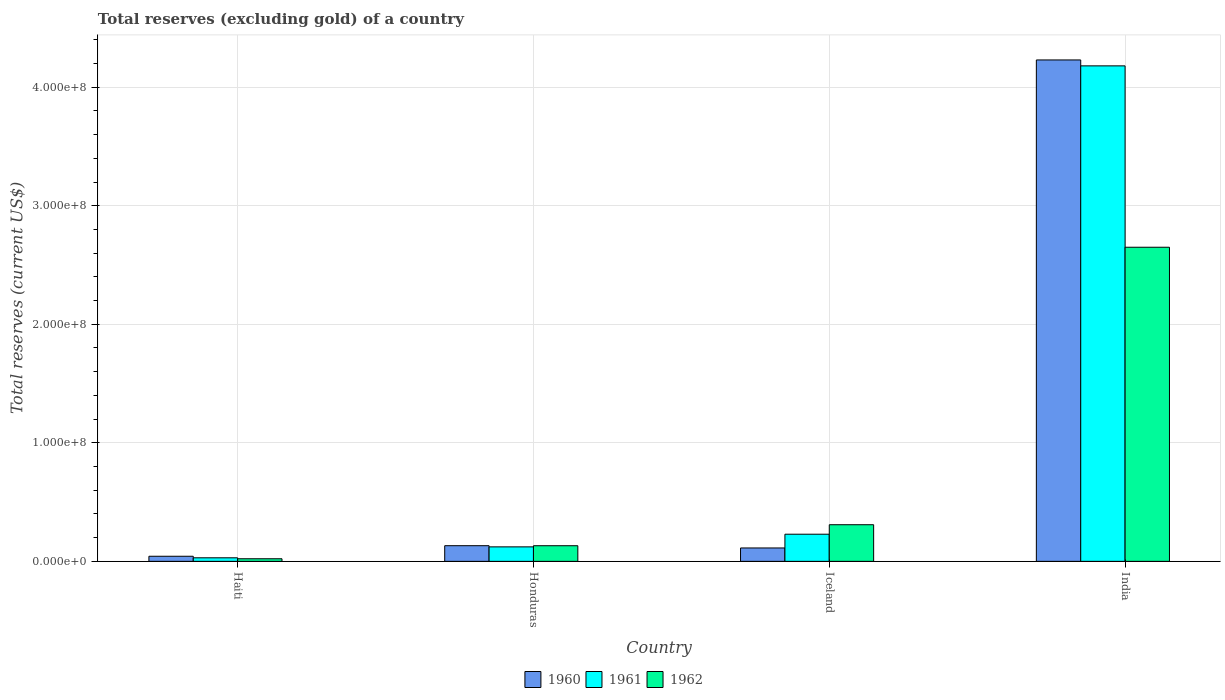How many different coloured bars are there?
Your answer should be compact. 3. Are the number of bars on each tick of the X-axis equal?
Keep it short and to the point. Yes. In how many cases, is the number of bars for a given country not equal to the number of legend labels?
Ensure brevity in your answer.  0. What is the total reserves (excluding gold) in 1962 in Honduras?
Keep it short and to the point. 1.32e+07. Across all countries, what is the maximum total reserves (excluding gold) in 1962?
Offer a very short reply. 2.65e+08. Across all countries, what is the minimum total reserves (excluding gold) in 1960?
Your response must be concise. 4.30e+06. In which country was the total reserves (excluding gold) in 1961 minimum?
Your response must be concise. Haiti. What is the total total reserves (excluding gold) in 1962 in the graph?
Ensure brevity in your answer.  3.11e+08. What is the difference between the total reserves (excluding gold) in 1961 in Honduras and that in India?
Your answer should be very brief. -4.06e+08. What is the difference between the total reserves (excluding gold) in 1960 in Iceland and the total reserves (excluding gold) in 1961 in Haiti?
Offer a terse response. 8.30e+06. What is the average total reserves (excluding gold) in 1961 per country?
Your response must be concise. 1.14e+08. What is the difference between the total reserves (excluding gold) of/in 1961 and total reserves (excluding gold) of/in 1960 in Iceland?
Your answer should be compact. 1.16e+07. In how many countries, is the total reserves (excluding gold) in 1961 greater than 20000000 US$?
Your answer should be very brief. 2. What is the ratio of the total reserves (excluding gold) in 1960 in Honduras to that in Iceland?
Your response must be concise. 1.17. Is the difference between the total reserves (excluding gold) in 1961 in Haiti and Iceland greater than the difference between the total reserves (excluding gold) in 1960 in Haiti and Iceland?
Your answer should be very brief. No. What is the difference between the highest and the second highest total reserves (excluding gold) in 1962?
Offer a terse response. 2.34e+08. What is the difference between the highest and the lowest total reserves (excluding gold) in 1960?
Offer a terse response. 4.19e+08. Is the sum of the total reserves (excluding gold) in 1962 in Honduras and Iceland greater than the maximum total reserves (excluding gold) in 1961 across all countries?
Offer a very short reply. No. How many bars are there?
Your answer should be very brief. 12. Are all the bars in the graph horizontal?
Your answer should be compact. No. How many countries are there in the graph?
Offer a very short reply. 4. What is the difference between two consecutive major ticks on the Y-axis?
Provide a succinct answer. 1.00e+08. Does the graph contain any zero values?
Keep it short and to the point. No. Does the graph contain grids?
Keep it short and to the point. Yes. Where does the legend appear in the graph?
Your answer should be compact. Bottom center. How many legend labels are there?
Provide a short and direct response. 3. What is the title of the graph?
Offer a terse response. Total reserves (excluding gold) of a country. What is the label or title of the Y-axis?
Your response must be concise. Total reserves (current US$). What is the Total reserves (current US$) in 1960 in Haiti?
Make the answer very short. 4.30e+06. What is the Total reserves (current US$) of 1962 in Haiti?
Give a very brief answer. 2.20e+06. What is the Total reserves (current US$) of 1960 in Honduras?
Give a very brief answer. 1.32e+07. What is the Total reserves (current US$) of 1961 in Honduras?
Make the answer very short. 1.22e+07. What is the Total reserves (current US$) of 1962 in Honduras?
Give a very brief answer. 1.32e+07. What is the Total reserves (current US$) in 1960 in Iceland?
Give a very brief answer. 1.13e+07. What is the Total reserves (current US$) of 1961 in Iceland?
Provide a succinct answer. 2.29e+07. What is the Total reserves (current US$) in 1962 in Iceland?
Offer a terse response. 3.09e+07. What is the Total reserves (current US$) of 1960 in India?
Keep it short and to the point. 4.23e+08. What is the Total reserves (current US$) in 1961 in India?
Provide a short and direct response. 4.18e+08. What is the Total reserves (current US$) of 1962 in India?
Make the answer very short. 2.65e+08. Across all countries, what is the maximum Total reserves (current US$) of 1960?
Make the answer very short. 4.23e+08. Across all countries, what is the maximum Total reserves (current US$) of 1961?
Offer a very short reply. 4.18e+08. Across all countries, what is the maximum Total reserves (current US$) of 1962?
Provide a succinct answer. 2.65e+08. Across all countries, what is the minimum Total reserves (current US$) of 1960?
Offer a terse response. 4.30e+06. Across all countries, what is the minimum Total reserves (current US$) of 1961?
Make the answer very short. 3.00e+06. Across all countries, what is the minimum Total reserves (current US$) of 1962?
Give a very brief answer. 2.20e+06. What is the total Total reserves (current US$) of 1960 in the graph?
Ensure brevity in your answer.  4.52e+08. What is the total Total reserves (current US$) of 1961 in the graph?
Provide a short and direct response. 4.56e+08. What is the total Total reserves (current US$) in 1962 in the graph?
Your answer should be very brief. 3.11e+08. What is the difference between the Total reserves (current US$) in 1960 in Haiti and that in Honduras?
Your response must be concise. -8.91e+06. What is the difference between the Total reserves (current US$) in 1961 in Haiti and that in Honduras?
Keep it short and to the point. -9.22e+06. What is the difference between the Total reserves (current US$) of 1962 in Haiti and that in Honduras?
Provide a short and direct response. -1.10e+07. What is the difference between the Total reserves (current US$) of 1960 in Haiti and that in Iceland?
Provide a short and direct response. -7.00e+06. What is the difference between the Total reserves (current US$) in 1961 in Haiti and that in Iceland?
Provide a short and direct response. -1.99e+07. What is the difference between the Total reserves (current US$) of 1962 in Haiti and that in Iceland?
Give a very brief answer. -2.87e+07. What is the difference between the Total reserves (current US$) in 1960 in Haiti and that in India?
Keep it short and to the point. -4.19e+08. What is the difference between the Total reserves (current US$) in 1961 in Haiti and that in India?
Offer a terse response. -4.15e+08. What is the difference between the Total reserves (current US$) in 1962 in Haiti and that in India?
Your response must be concise. -2.63e+08. What is the difference between the Total reserves (current US$) in 1960 in Honduras and that in Iceland?
Ensure brevity in your answer.  1.91e+06. What is the difference between the Total reserves (current US$) in 1961 in Honduras and that in Iceland?
Provide a short and direct response. -1.07e+07. What is the difference between the Total reserves (current US$) in 1962 in Honduras and that in Iceland?
Offer a terse response. -1.77e+07. What is the difference between the Total reserves (current US$) of 1960 in Honduras and that in India?
Keep it short and to the point. -4.10e+08. What is the difference between the Total reserves (current US$) of 1961 in Honduras and that in India?
Your answer should be compact. -4.06e+08. What is the difference between the Total reserves (current US$) in 1962 in Honduras and that in India?
Your answer should be very brief. -2.52e+08. What is the difference between the Total reserves (current US$) of 1960 in Iceland and that in India?
Your answer should be compact. -4.12e+08. What is the difference between the Total reserves (current US$) in 1961 in Iceland and that in India?
Your answer should be very brief. -3.95e+08. What is the difference between the Total reserves (current US$) in 1962 in Iceland and that in India?
Give a very brief answer. -2.34e+08. What is the difference between the Total reserves (current US$) of 1960 in Haiti and the Total reserves (current US$) of 1961 in Honduras?
Your answer should be very brief. -7.92e+06. What is the difference between the Total reserves (current US$) in 1960 in Haiti and the Total reserves (current US$) in 1962 in Honduras?
Your response must be concise. -8.89e+06. What is the difference between the Total reserves (current US$) in 1961 in Haiti and the Total reserves (current US$) in 1962 in Honduras?
Your response must be concise. -1.02e+07. What is the difference between the Total reserves (current US$) in 1960 in Haiti and the Total reserves (current US$) in 1961 in Iceland?
Offer a very short reply. -1.86e+07. What is the difference between the Total reserves (current US$) of 1960 in Haiti and the Total reserves (current US$) of 1962 in Iceland?
Give a very brief answer. -2.66e+07. What is the difference between the Total reserves (current US$) of 1961 in Haiti and the Total reserves (current US$) of 1962 in Iceland?
Your response must be concise. -2.79e+07. What is the difference between the Total reserves (current US$) of 1960 in Haiti and the Total reserves (current US$) of 1961 in India?
Provide a short and direct response. -4.14e+08. What is the difference between the Total reserves (current US$) of 1960 in Haiti and the Total reserves (current US$) of 1962 in India?
Keep it short and to the point. -2.61e+08. What is the difference between the Total reserves (current US$) of 1961 in Haiti and the Total reserves (current US$) of 1962 in India?
Your answer should be very brief. -2.62e+08. What is the difference between the Total reserves (current US$) in 1960 in Honduras and the Total reserves (current US$) in 1961 in Iceland?
Offer a very short reply. -9.69e+06. What is the difference between the Total reserves (current US$) of 1960 in Honduras and the Total reserves (current US$) of 1962 in Iceland?
Keep it short and to the point. -1.77e+07. What is the difference between the Total reserves (current US$) of 1961 in Honduras and the Total reserves (current US$) of 1962 in Iceland?
Give a very brief answer. -1.87e+07. What is the difference between the Total reserves (current US$) of 1960 in Honduras and the Total reserves (current US$) of 1961 in India?
Provide a short and direct response. -4.05e+08. What is the difference between the Total reserves (current US$) of 1960 in Honduras and the Total reserves (current US$) of 1962 in India?
Keep it short and to the point. -2.52e+08. What is the difference between the Total reserves (current US$) of 1961 in Honduras and the Total reserves (current US$) of 1962 in India?
Your answer should be very brief. -2.53e+08. What is the difference between the Total reserves (current US$) in 1960 in Iceland and the Total reserves (current US$) in 1961 in India?
Keep it short and to the point. -4.07e+08. What is the difference between the Total reserves (current US$) in 1960 in Iceland and the Total reserves (current US$) in 1962 in India?
Your answer should be very brief. -2.54e+08. What is the difference between the Total reserves (current US$) in 1961 in Iceland and the Total reserves (current US$) in 1962 in India?
Provide a succinct answer. -2.42e+08. What is the average Total reserves (current US$) in 1960 per country?
Give a very brief answer. 1.13e+08. What is the average Total reserves (current US$) in 1961 per country?
Your response must be concise. 1.14e+08. What is the average Total reserves (current US$) of 1962 per country?
Give a very brief answer. 7.78e+07. What is the difference between the Total reserves (current US$) in 1960 and Total reserves (current US$) in 1961 in Haiti?
Provide a succinct answer. 1.30e+06. What is the difference between the Total reserves (current US$) in 1960 and Total reserves (current US$) in 1962 in Haiti?
Provide a succinct answer. 2.10e+06. What is the difference between the Total reserves (current US$) in 1960 and Total reserves (current US$) in 1961 in Honduras?
Keep it short and to the point. 9.90e+05. What is the difference between the Total reserves (current US$) of 1961 and Total reserves (current US$) of 1962 in Honduras?
Provide a succinct answer. -9.70e+05. What is the difference between the Total reserves (current US$) in 1960 and Total reserves (current US$) in 1961 in Iceland?
Ensure brevity in your answer.  -1.16e+07. What is the difference between the Total reserves (current US$) in 1960 and Total reserves (current US$) in 1962 in Iceland?
Give a very brief answer. -1.96e+07. What is the difference between the Total reserves (current US$) in 1961 and Total reserves (current US$) in 1962 in Iceland?
Ensure brevity in your answer.  -8.00e+06. What is the difference between the Total reserves (current US$) of 1960 and Total reserves (current US$) of 1961 in India?
Make the answer very short. 5.00e+06. What is the difference between the Total reserves (current US$) in 1960 and Total reserves (current US$) in 1962 in India?
Provide a succinct answer. 1.58e+08. What is the difference between the Total reserves (current US$) in 1961 and Total reserves (current US$) in 1962 in India?
Your response must be concise. 1.53e+08. What is the ratio of the Total reserves (current US$) of 1960 in Haiti to that in Honduras?
Offer a very short reply. 0.33. What is the ratio of the Total reserves (current US$) of 1961 in Haiti to that in Honduras?
Offer a very short reply. 0.25. What is the ratio of the Total reserves (current US$) of 1962 in Haiti to that in Honduras?
Give a very brief answer. 0.17. What is the ratio of the Total reserves (current US$) of 1960 in Haiti to that in Iceland?
Make the answer very short. 0.38. What is the ratio of the Total reserves (current US$) of 1961 in Haiti to that in Iceland?
Your answer should be compact. 0.13. What is the ratio of the Total reserves (current US$) of 1962 in Haiti to that in Iceland?
Make the answer very short. 0.07. What is the ratio of the Total reserves (current US$) in 1960 in Haiti to that in India?
Provide a short and direct response. 0.01. What is the ratio of the Total reserves (current US$) in 1961 in Haiti to that in India?
Your response must be concise. 0.01. What is the ratio of the Total reserves (current US$) in 1962 in Haiti to that in India?
Make the answer very short. 0.01. What is the ratio of the Total reserves (current US$) of 1960 in Honduras to that in Iceland?
Provide a short and direct response. 1.17. What is the ratio of the Total reserves (current US$) in 1961 in Honduras to that in Iceland?
Keep it short and to the point. 0.53. What is the ratio of the Total reserves (current US$) of 1962 in Honduras to that in Iceland?
Provide a succinct answer. 0.43. What is the ratio of the Total reserves (current US$) in 1960 in Honduras to that in India?
Your answer should be compact. 0.03. What is the ratio of the Total reserves (current US$) of 1961 in Honduras to that in India?
Make the answer very short. 0.03. What is the ratio of the Total reserves (current US$) in 1962 in Honduras to that in India?
Provide a succinct answer. 0.05. What is the ratio of the Total reserves (current US$) in 1960 in Iceland to that in India?
Ensure brevity in your answer.  0.03. What is the ratio of the Total reserves (current US$) of 1961 in Iceland to that in India?
Keep it short and to the point. 0.05. What is the ratio of the Total reserves (current US$) in 1962 in Iceland to that in India?
Your answer should be compact. 0.12. What is the difference between the highest and the second highest Total reserves (current US$) of 1960?
Provide a succinct answer. 4.10e+08. What is the difference between the highest and the second highest Total reserves (current US$) in 1961?
Your answer should be very brief. 3.95e+08. What is the difference between the highest and the second highest Total reserves (current US$) in 1962?
Offer a very short reply. 2.34e+08. What is the difference between the highest and the lowest Total reserves (current US$) in 1960?
Provide a succinct answer. 4.19e+08. What is the difference between the highest and the lowest Total reserves (current US$) in 1961?
Provide a succinct answer. 4.15e+08. What is the difference between the highest and the lowest Total reserves (current US$) in 1962?
Give a very brief answer. 2.63e+08. 